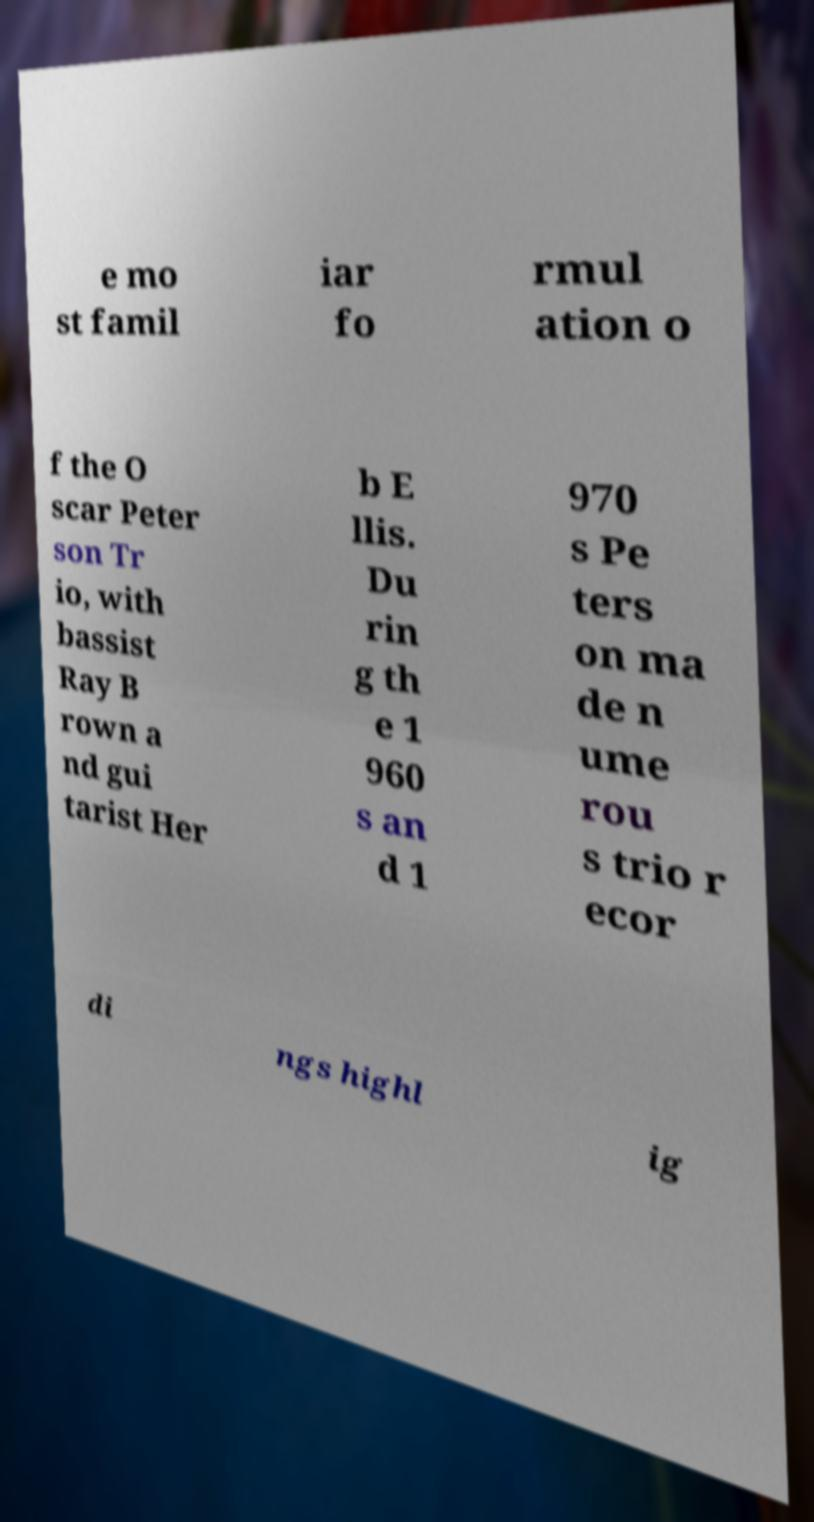There's text embedded in this image that I need extracted. Can you transcribe it verbatim? e mo st famil iar fo rmul ation o f the O scar Peter son Tr io, with bassist Ray B rown a nd gui tarist Her b E llis. Du rin g th e 1 960 s an d 1 970 s Pe ters on ma de n ume rou s trio r ecor di ngs highl ig 